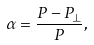<formula> <loc_0><loc_0><loc_500><loc_500>\alpha = \frac { P - P _ { \perp } } { P } ,</formula> 